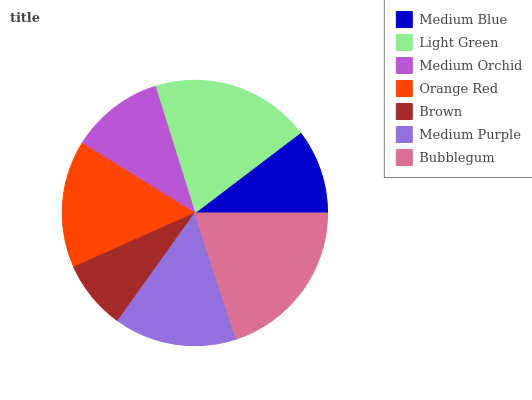Is Brown the minimum?
Answer yes or no. Yes. Is Bubblegum the maximum?
Answer yes or no. Yes. Is Light Green the minimum?
Answer yes or no. No. Is Light Green the maximum?
Answer yes or no. No. Is Light Green greater than Medium Blue?
Answer yes or no. Yes. Is Medium Blue less than Light Green?
Answer yes or no. Yes. Is Medium Blue greater than Light Green?
Answer yes or no. No. Is Light Green less than Medium Blue?
Answer yes or no. No. Is Medium Purple the high median?
Answer yes or no. Yes. Is Medium Purple the low median?
Answer yes or no. Yes. Is Orange Red the high median?
Answer yes or no. No. Is Medium Blue the low median?
Answer yes or no. No. 